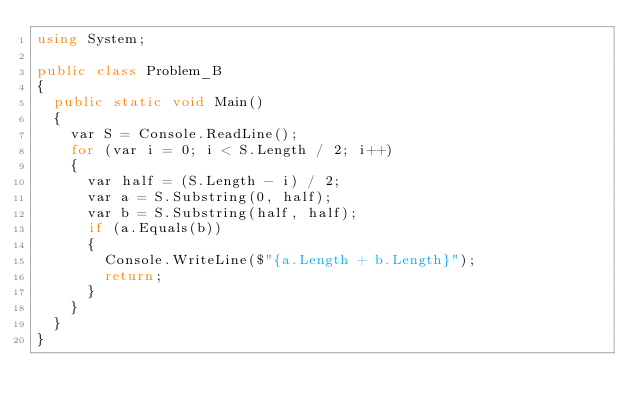Convert code to text. <code><loc_0><loc_0><loc_500><loc_500><_C#_>using System;

public class Problem_B
{
  public static void Main()
  {
    var S = Console.ReadLine();
    for (var i = 0; i < S.Length / 2; i++)
    {
      var half = (S.Length - i) / 2;
      var a = S.Substring(0, half);
      var b = S.Substring(half, half);
      if (a.Equals(b))
      {
        Console.WriteLine($"{a.Length + b.Length}");
        return;
      }
    }
  }
}
</code> 